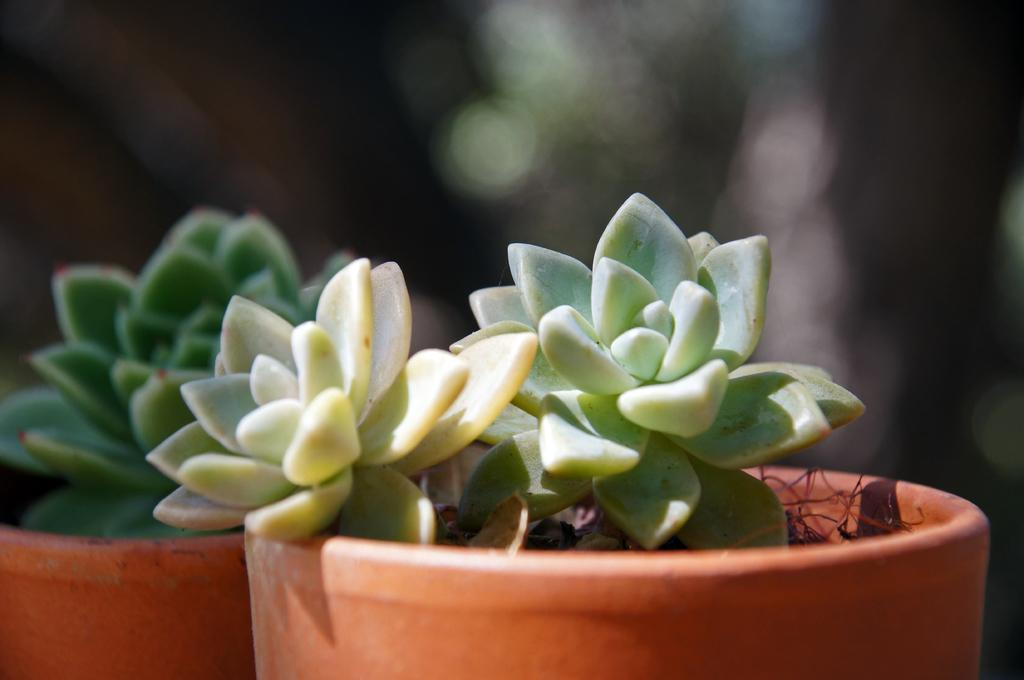How many flower pots are visible in the image? There are two flower pots in the image. What is the color of the flower pots? The flower pots are brown in color. What is growing in the flower pots? There are plants in the flower pots. What is the color of the plants? The plants are green in color. Can you describe the background of the image? The background of the image is blurry. What type of mist can be seen coming from the top of the flower pots in the image? There is no mist present in the image; it only features two brown flower pots with green plants inside. 